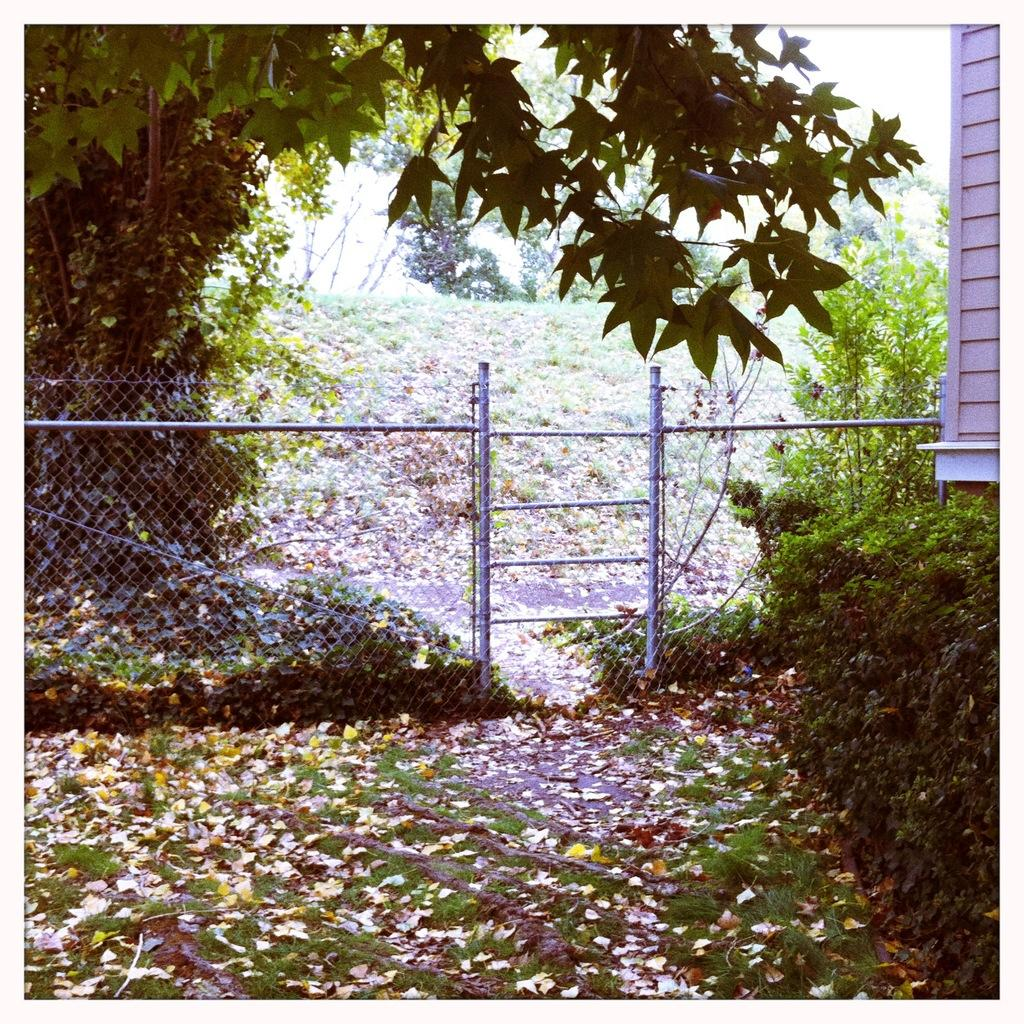What is located in the center of the image? There is a fence in the center of the image. What type of structure can be seen in the image? There is a wooden wall in the image. What type of vegetation is present in the image? Trees, plants, and grass are visible in the image. What additional detail can be observed in the image? Dry leaves are visible in the image. What type of jeans is the church wearing in the image? There is no church or jeans present in the image. What type of map can be seen in the image? There is no map present in the image. 